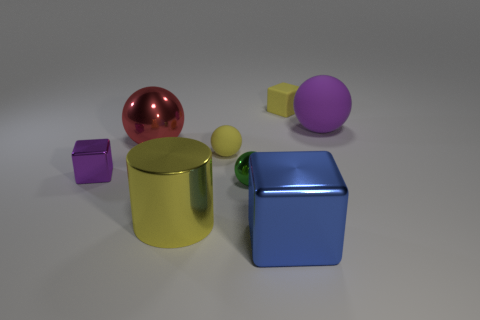There is a blue object that is the same size as the purple rubber sphere; what is its shape?
Your answer should be very brief. Cube. There is a shiny thing to the right of the small ball that is in front of the cube left of the yellow metallic thing; what shape is it?
Give a very brief answer. Cube. There is a block that is behind the big purple ball; does it have the same color as the rubber ball that is left of the small green shiny object?
Offer a terse response. Yes. What number of metal cylinders are there?
Give a very brief answer. 1. There is a tiny yellow sphere; are there any cubes on the left side of it?
Make the answer very short. Yes. Do the small cube that is to the left of the blue block and the small ball that is behind the tiny purple metal thing have the same material?
Offer a very short reply. No. Is the number of blue metal blocks that are behind the small purple metallic block less than the number of red shiny cylinders?
Your answer should be very brief. No. What color is the small metallic thing that is behind the green metal ball?
Offer a very short reply. Purple. There is a purple thing that is behind the small block in front of the big red object; what is it made of?
Offer a terse response. Rubber. Is there a purple metal cube that has the same size as the yellow matte sphere?
Offer a very short reply. Yes. 